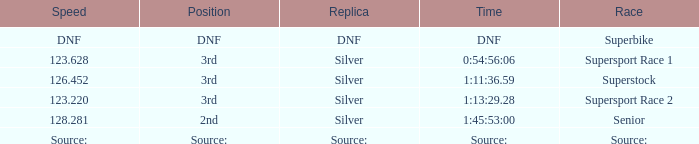I'm looking to parse the entire table for insights. Could you assist me with that? {'header': ['Speed', 'Position', 'Replica', 'Time', 'Race'], 'rows': [['DNF', 'DNF', 'DNF', 'DNF', 'Superbike'], ['123.628', '3rd', 'Silver', '0:54:56:06', 'Supersport Race 1'], ['126.452', '3rd', 'Silver', '1:11:36.59', 'Superstock'], ['123.220', '3rd', 'Silver', '1:13:29.28', 'Supersport Race 2'], ['128.281', '2nd', 'Silver', '1:45:53:00', 'Senior'], ['Source:', 'Source:', 'Source:', 'Source:', 'Source:']]} Which race has a position of 3rd and a speed of 126.452? Superstock. 